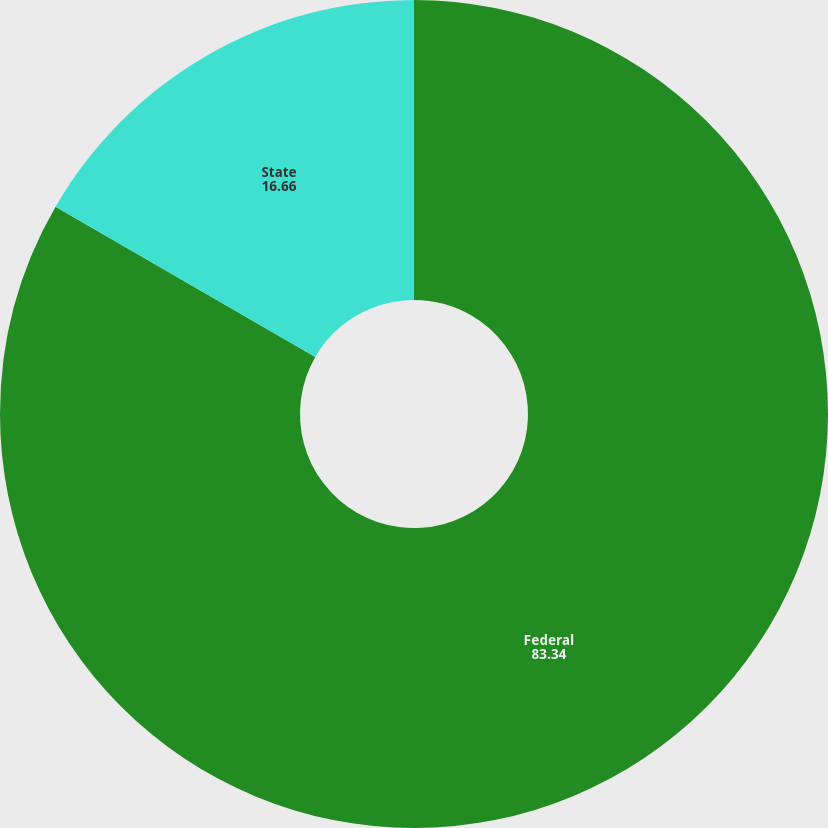Convert chart. <chart><loc_0><loc_0><loc_500><loc_500><pie_chart><fcel>Federal<fcel>State<nl><fcel>83.34%<fcel>16.66%<nl></chart> 